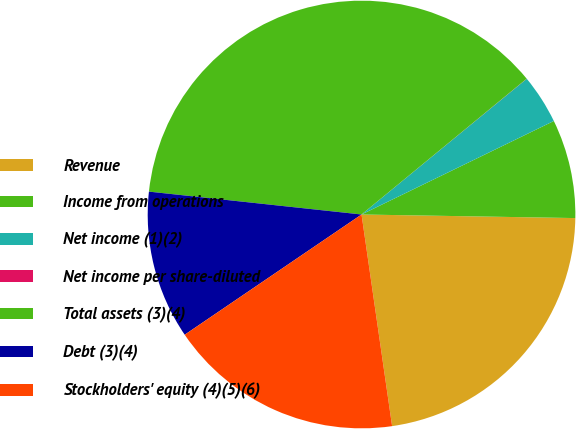Convert chart to OTSL. <chart><loc_0><loc_0><loc_500><loc_500><pie_chart><fcel>Revenue<fcel>Income from operations<fcel>Net income (1)(2)<fcel>Net income per share-diluted<fcel>Total assets (3)(4)<fcel>Debt (3)(4)<fcel>Stockholders' equity (4)(5)(6)<nl><fcel>22.45%<fcel>7.47%<fcel>3.74%<fcel>0.01%<fcel>37.34%<fcel>11.21%<fcel>17.78%<nl></chart> 